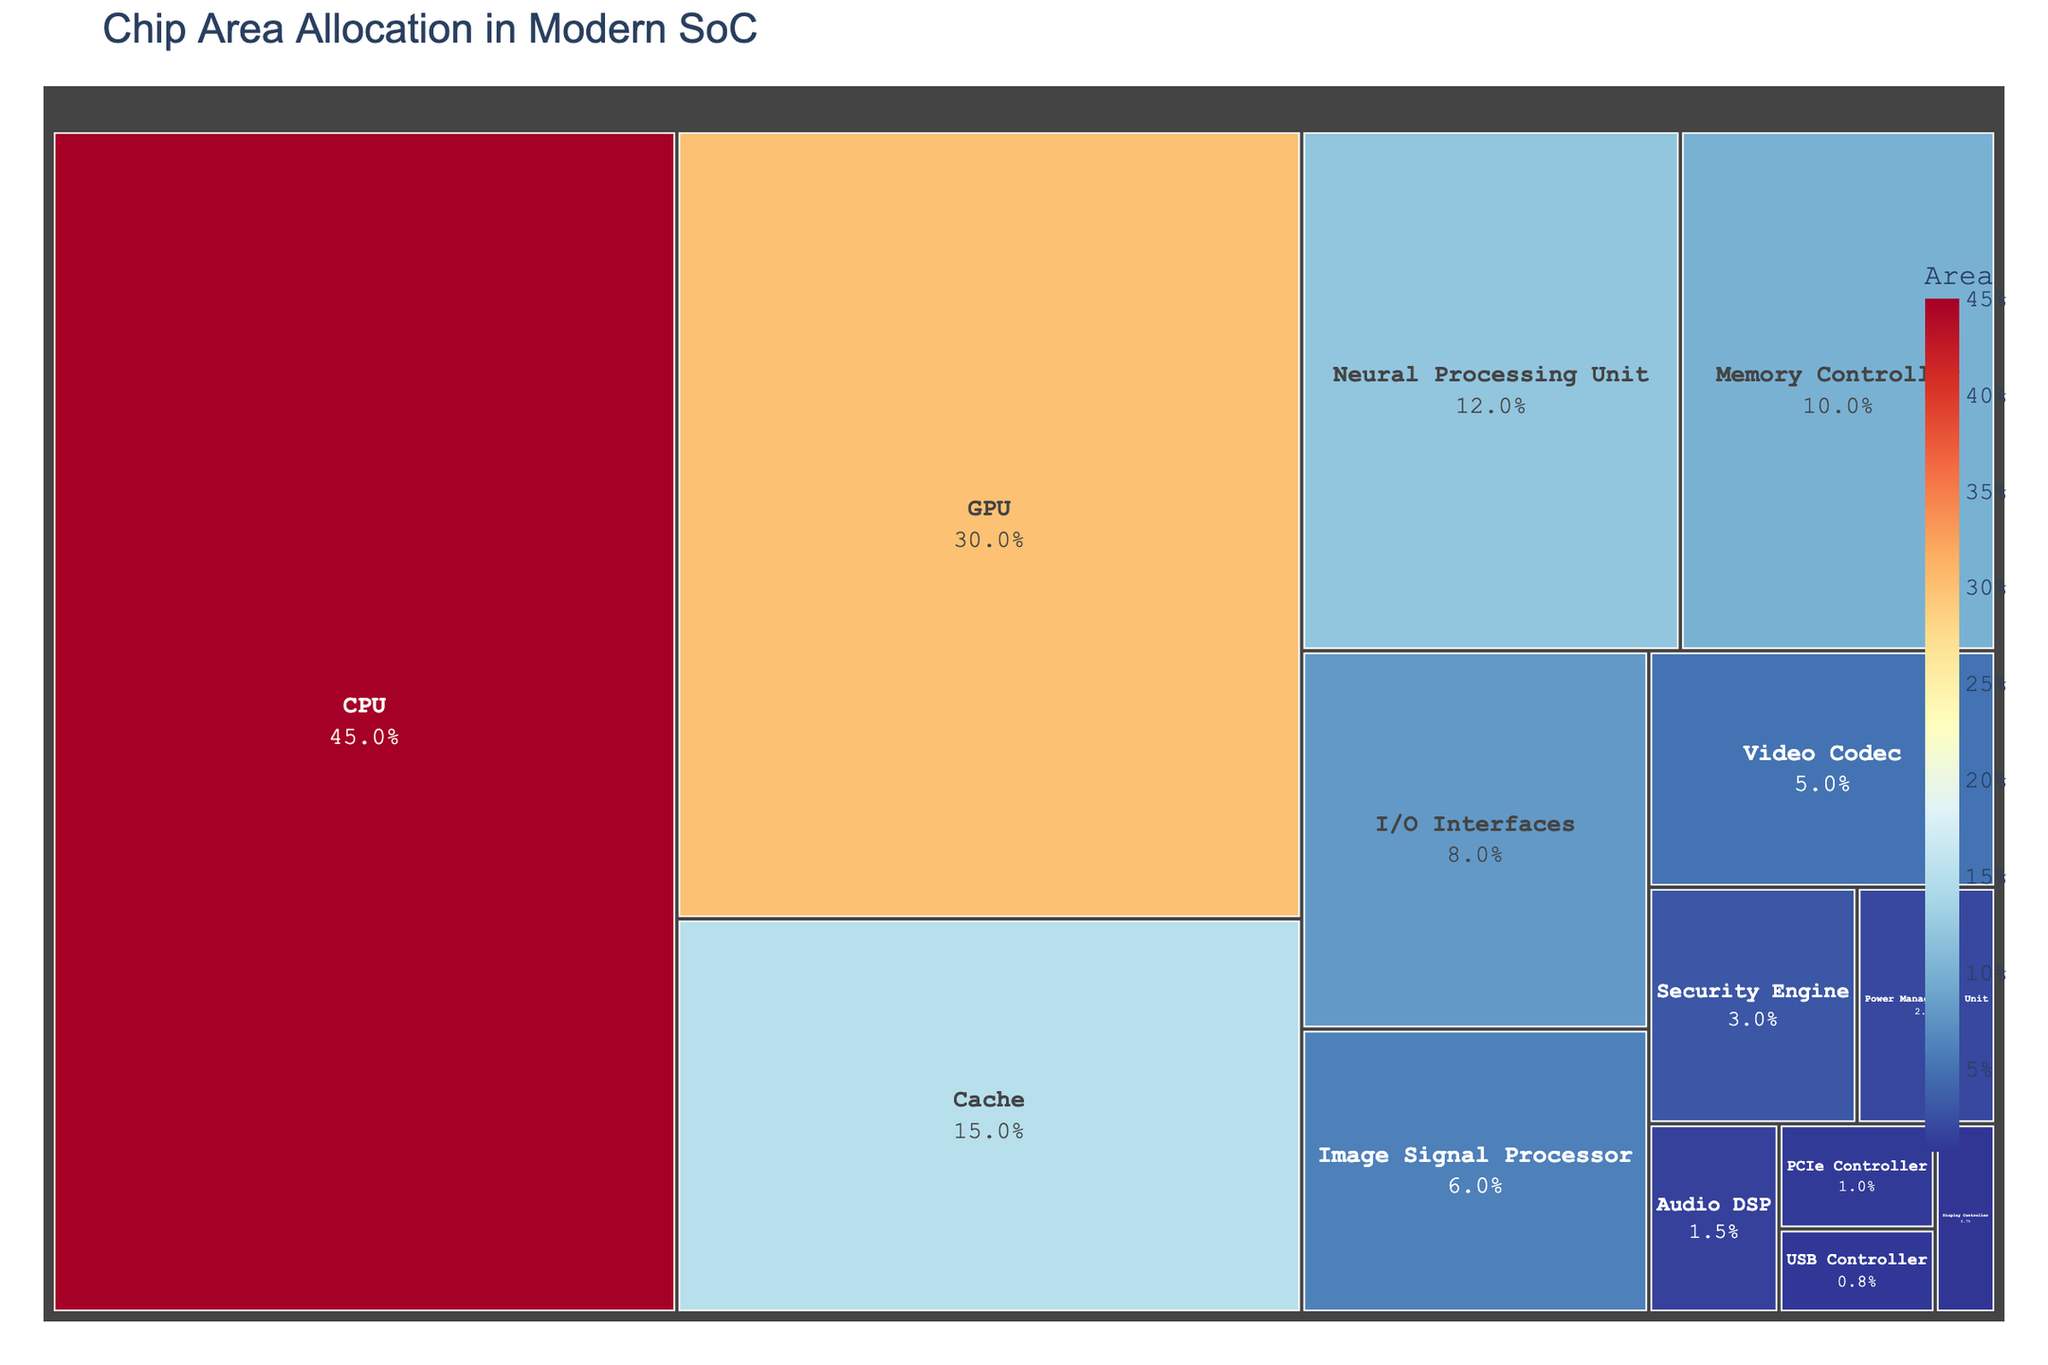Which component occupies the largest area? Look at the treemap and identify the component with the largest box. The title specifies it's about chip area allocation. The CPU has the largest box, which means it occupies the largest area.
Answer: CPU Which component occupies the smallest area? Look at the treemap and identify the component with the smallest box. The Display Controller has the smallest box, indicating it occupies the least area.
Answer: Display Controller How much larger is the area of the CPU compared to the Neural Processing Unit? Find the area values for the CPU and Neural Processing Unit from the treemap. Subtract the NPU's area (12%) from the CPU's area (45%).
Answer: 33% What is the combined area of the GPU and Video Codec? Locate the GPU and Video Codec areas in the treemap. Add the GPU's area (30%) and Video Codec's area (5%).
Answer: 35% Which component is dedicated to power management, and what is its area? Identify the component named "Power Management Unit" in the treemap and note its area.
Answer: Power Management Unit, 2% Which has a larger area: Cache or Image Signal Processor? Compare the areas of Cache and Image Signal Processor by finding their boxes on the treemap. The Cache (15%) is larger than the Image Signal Processor (6%).
Answer: Cache How many components have an area less than 5%? Count the number of boxes in the treemap with an area value displayed as less than 5%. The components are Video Codec (5%), Security Engine (3%), Power Management Unit (2%), Audio DSP (1.5%), PCIe Controller (1%), USB Controller (0.8%), and Display Controller (0.7%). There are 7 components.
Answer: 7 Which functional unit dedicated to image processing, and how does its area compare to the memory controller? Identify the component related to image processing, which is the Image Signal Processor. Compare its area with the Memory Controller by finding their areas in the treemap. Image Signal Processor (6%) is smaller than Memory Controller (10%).
Answer: Image Signal Processor, it is smaller What percentage of the total area is occupied by Cache and Neural Processing Unit combined? Find the areas of Cache and Neural Processing Unit in the treemap. Add these values: Cache (15%) + Neural Processing Unit (12%) = 27%.
Answer: 27% Is the I/O Interfaces area larger than the Security Engine area? Compare the area values for I/O Interfaces (8%) and Security Engine (3%) displayed in the treemap. The I/O Interfaces area is larger.
Answer: Yes 